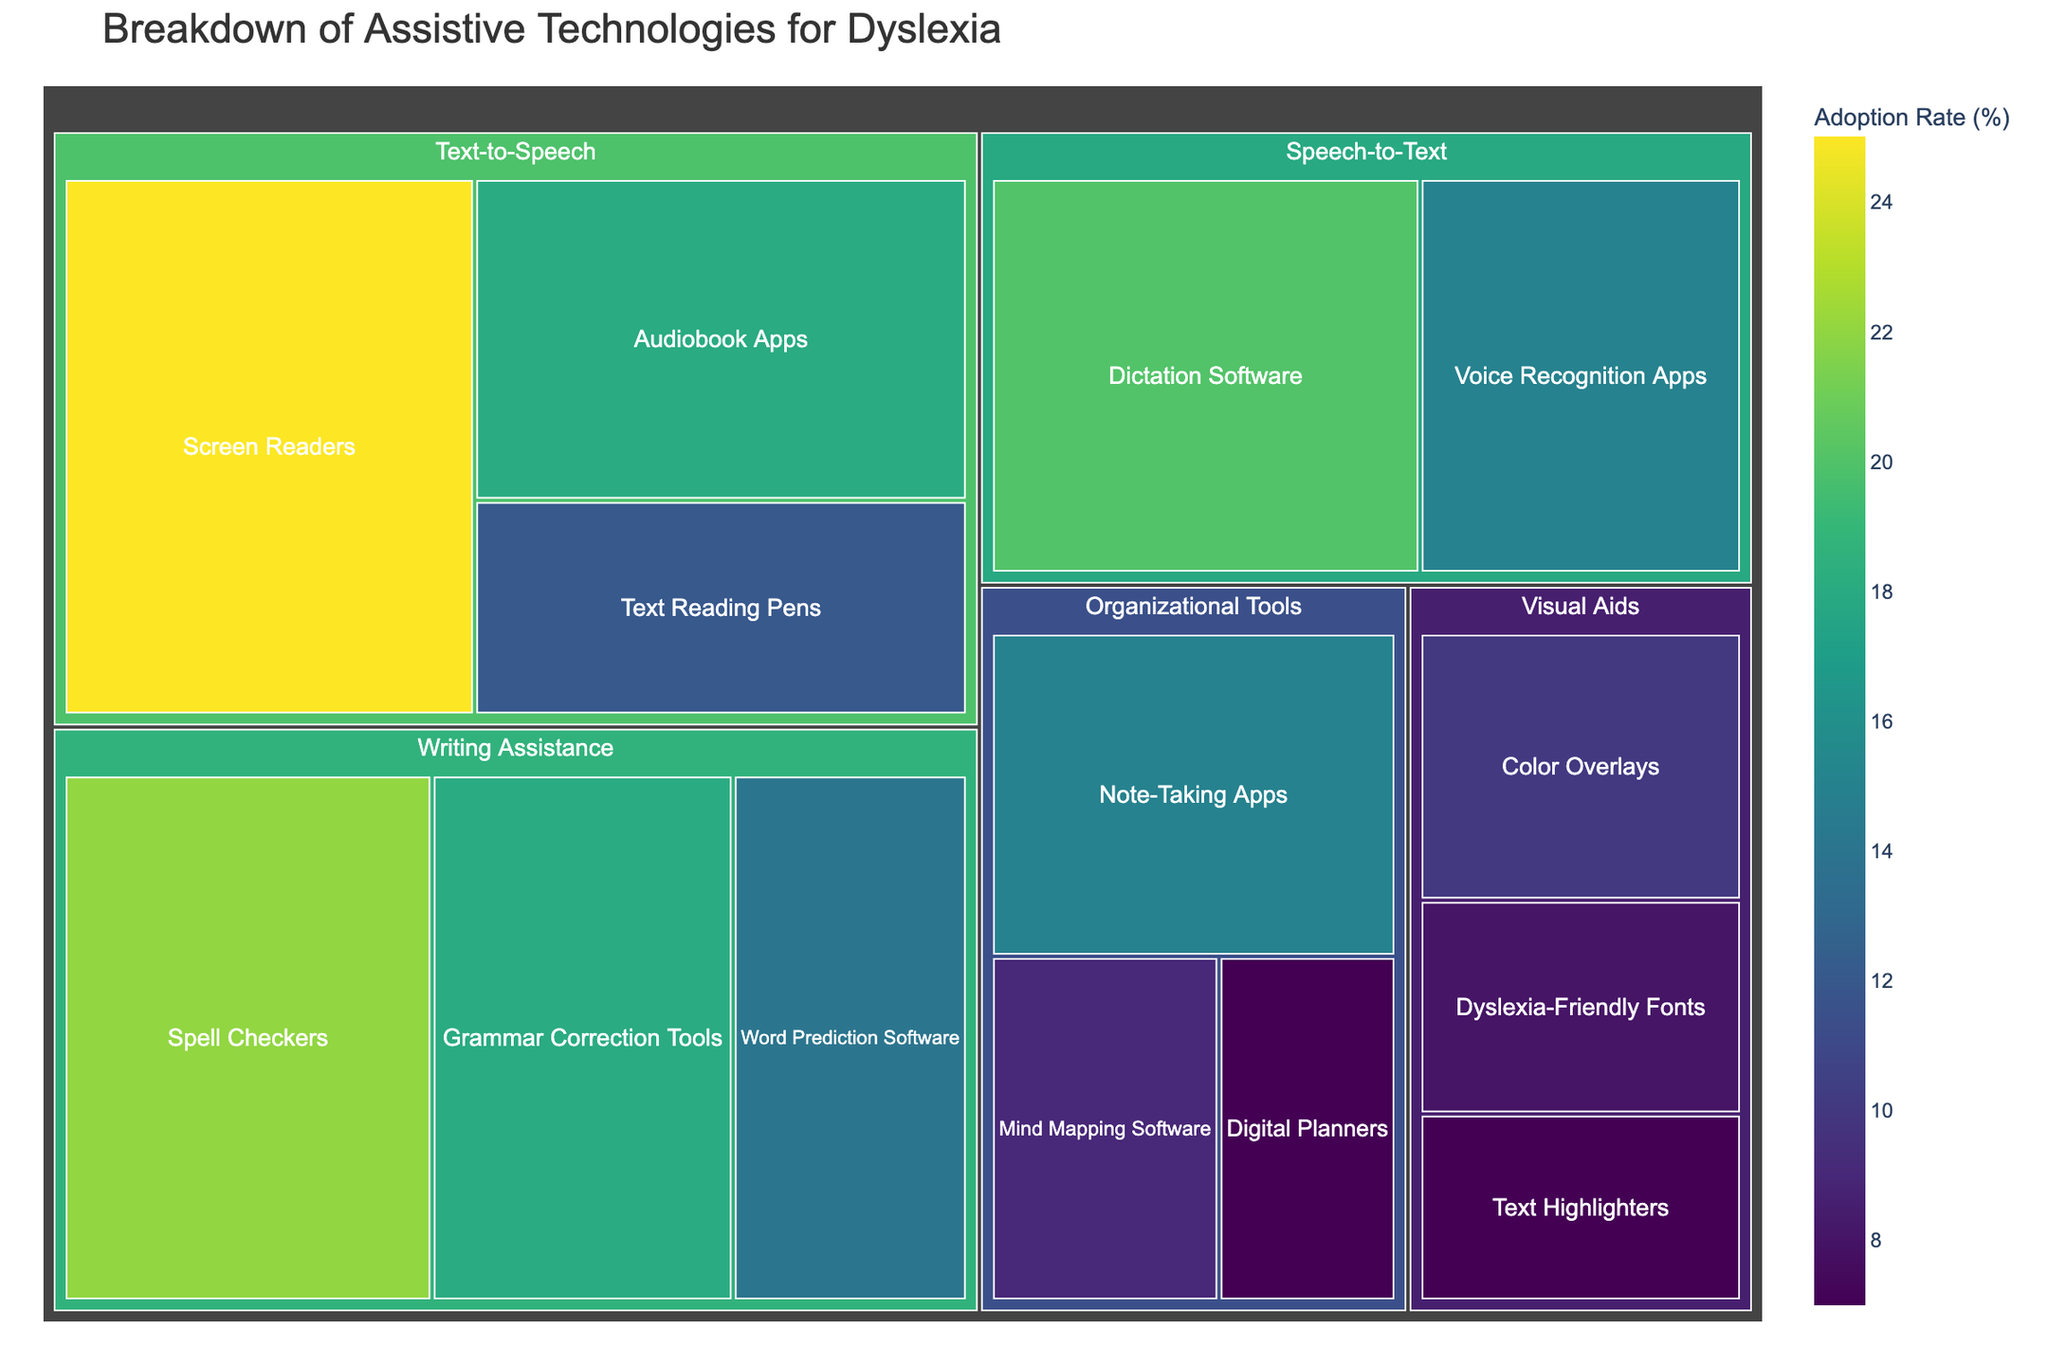How is the "Breakdown of Assistive Technologies for Dyslexia" categorized in the figure? The figure categorizes assistive technologies for dyslexia by "Category" and further by "Type" within those categories.
Answer: By Category and Type Which "Text-to-Speech" type has the highest adoption rate? Within the "Text-to-Speech" category, the "Screen Readers" type has the highest adoption rate of 25%.
Answer: Screen Readers What is the total adoption rate for all categories combined? Summing up all adoption rates: 25 + 18 + 12 + 20 + 15 + 10 + 8 + 7 + 22 + 18 + 14 + 9 + 7 + 15 = 200.
Answer: 200 Which category has the most diverse range of types? The "Writing Assistance" category has three types: Spell Checkers, Grammar Correction Tools, and Word Prediction Software, the same count as "Organizational Tools".
Answer: Writing Assistance Are there more assistive technologies types in "Visual Aids" or "Organizational Tools"? Both "Visual Aids" and "Organizational Tools" have three types each.
Answer: Equal What is the difference in adoption rates between "Spell Checkers" and "Voice Recognition Apps"? Spell Checkers have an adoption rate of 22%, and Voice Recognition Apps have 15%, so the difference is 22 - 15 = 7%.
Answer: 7% Which category type has the lowest adoption rate? The "Text Highlighters" type within the "Visual Aids" category has the lowest adoption rate of 7%.
Answer: Text Highlighters In the "Organizational Tools" category, which type has the highest adoption rate? The "Note-Taking Apps" type has the highest adoption rate of 15% in the "Organizational Tools" category.
Answer: Note-Taking Apps Compare the adoption rates of "Dictation Software" and "Mind Mapping Software". "Dictation Software" has an adoption rate of 20%, while "Mind Mapping Software" has 9%, so Dictation Software has a higher adoption rate by 20 - 9 = 11%.
Answer: Dictation Software by 11% What is the average adoption rate of the types in the "Speech-to-Text" category? Adding the adoption rates of "Dictation Software" (20%) and "Voice Recognition Apps" (15%) gives 20 + 15 = 35; the average is 35 / 2 = 17.5%.
Answer: 17.5% 